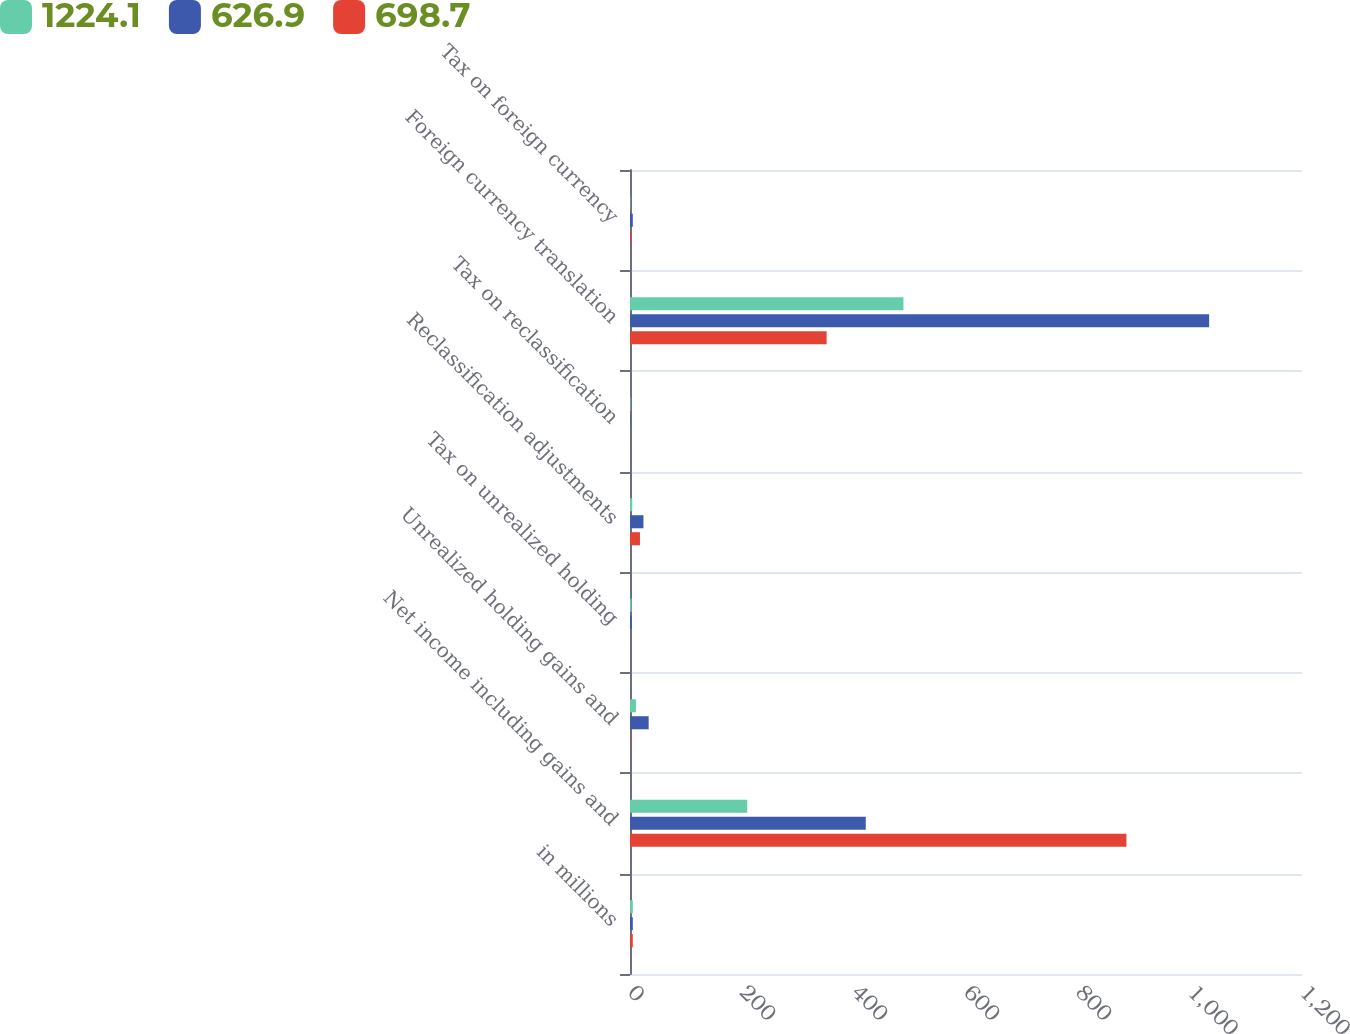<chart> <loc_0><loc_0><loc_500><loc_500><stacked_bar_chart><ecel><fcel>in millions<fcel>Net income including gains and<fcel>Unrealized holding gains and<fcel>Tax on unrealized holding<fcel>Reclassification adjustments<fcel>Tax on reclassification<fcel>Foreign currency translation<fcel>Tax on foreign currency<nl><fcel>1224.1<fcel>5<fcel>209.3<fcel>10.6<fcel>2.8<fcel>4<fcel>1.1<fcel>488.3<fcel>0.7<nl><fcel>626.9<fcel>5<fcel>421<fcel>33.3<fcel>3.2<fcel>24<fcel>0.9<fcel>1034.2<fcel>5<nl><fcel>698.7<fcel>5<fcel>886.5<fcel>1<fcel>0.2<fcel>17.8<fcel>0.2<fcel>351.1<fcel>1.7<nl></chart> 